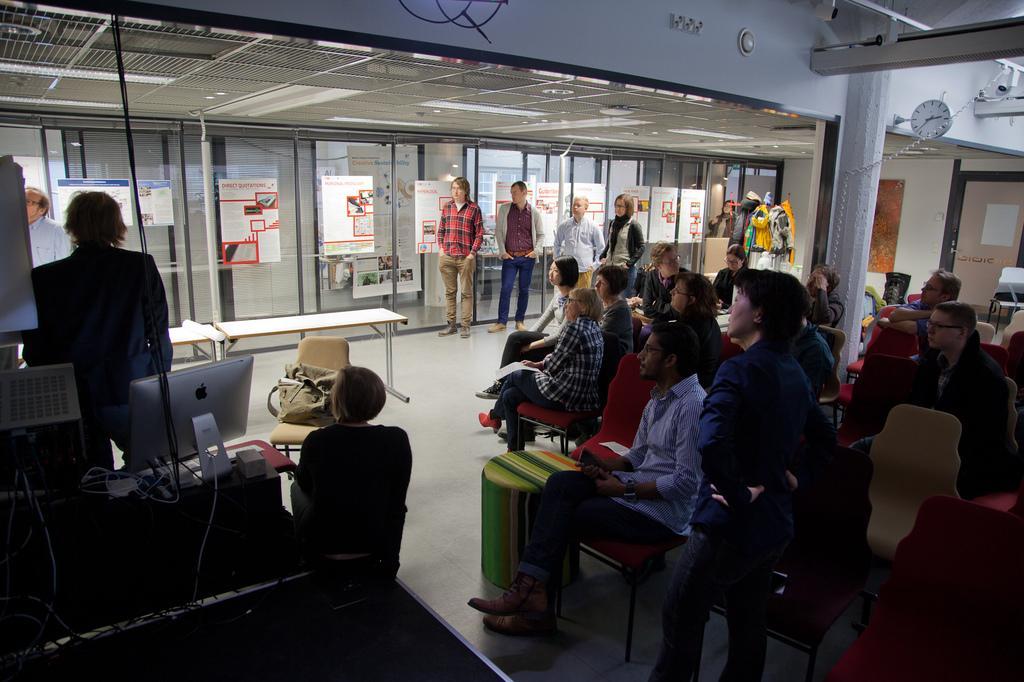In one or two sentences, can you explain what this image depicts? The picture is taken during a meeting. In the foreground of the picture there are people sitting in chairs. On the left there are cables, people, monitor and other objects. In the center of the background there are people, glass windows, posters, poles and other objects. At the top it is ceiling. On the right there is a clock and a CCTV camera. 